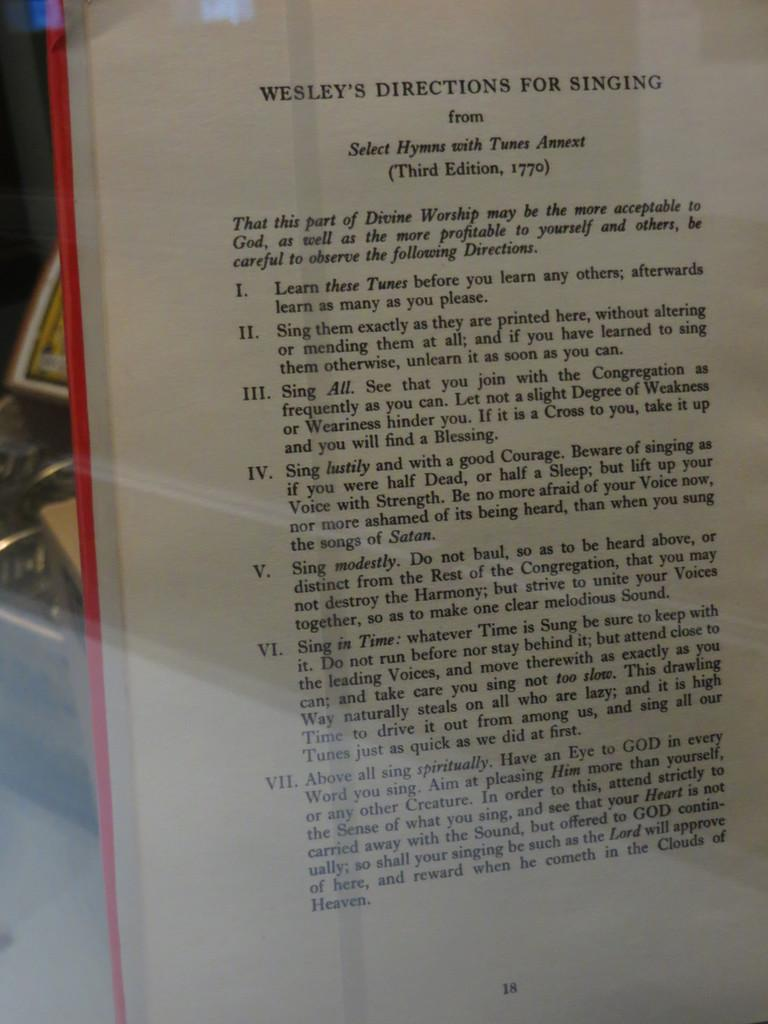<image>
Give a short and clear explanation of the subsequent image. The book gives a person directions for Singing. 